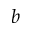Convert formula to latex. <formula><loc_0><loc_0><loc_500><loc_500>b</formula> 